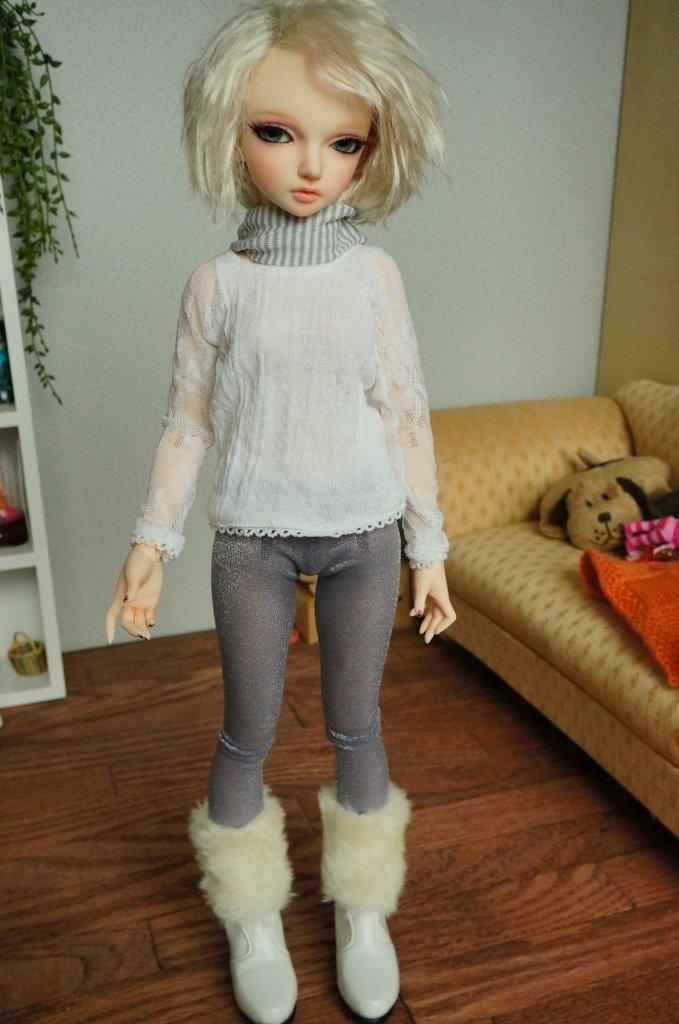Could you give a brief overview of what you see in this image? In this image there is a doll, and at the background there is a toy, clothes on the couch, some objects in the racks, wall, plant. 